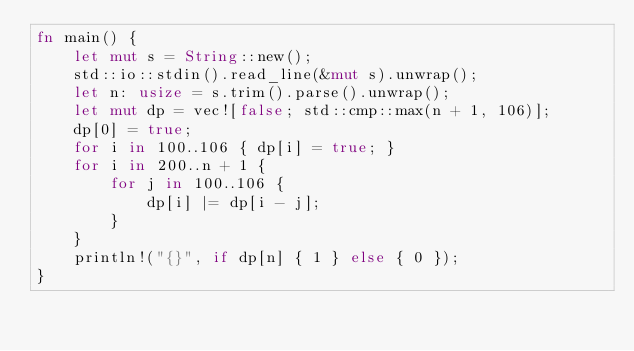Convert code to text. <code><loc_0><loc_0><loc_500><loc_500><_Rust_>fn main() {
    let mut s = String::new();
    std::io::stdin().read_line(&mut s).unwrap();
    let n: usize = s.trim().parse().unwrap();
    let mut dp = vec![false; std::cmp::max(n + 1, 106)];
    dp[0] = true;
    for i in 100..106 { dp[i] = true; }
    for i in 200..n + 1 {
        for j in 100..106 {
            dp[i] |= dp[i - j];
        }
    }
    println!("{}", if dp[n] { 1 } else { 0 });
}</code> 